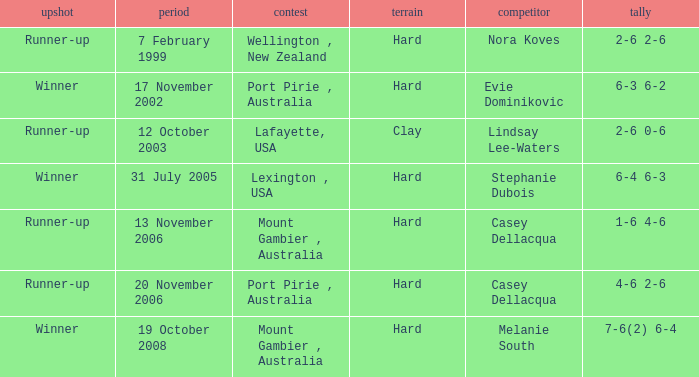Which is the Outcome on 13 november 2006? Runner-up. 